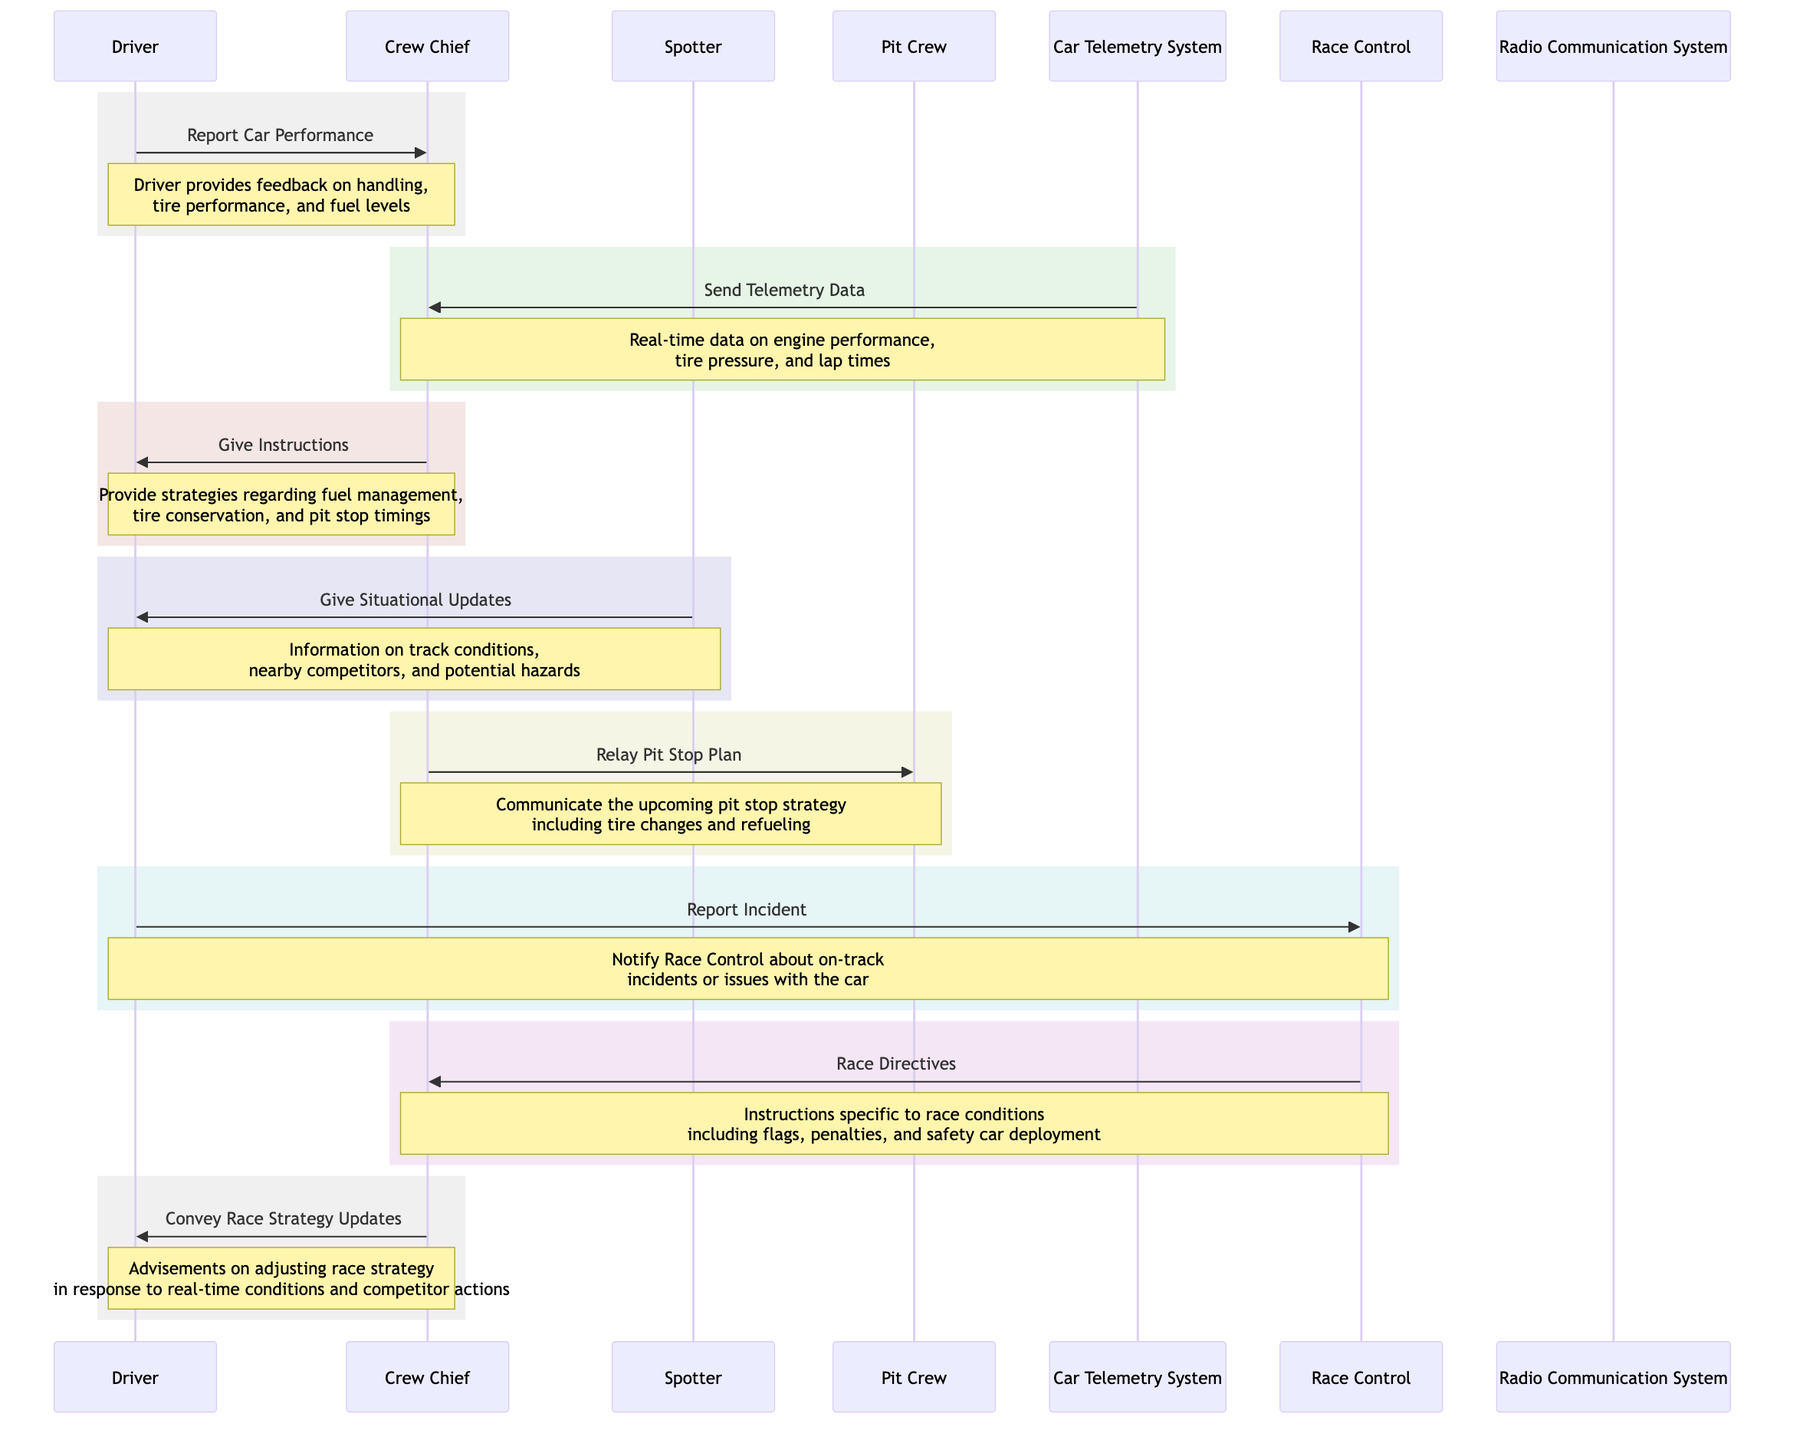What's the first action the Driver takes? The first action is "Report Car Performance," which indicates that the Driver communicates with the Crew Chief to provide feedback on the car's performance. This is the first message shown in the diagram.
Answer: Report Car Performance How many messages does the Crew Chief send? The Crew Chief sends three messages in total: "Give Instructions" to the Driver, "Relay Pit Stop Plan" to the Pit Crew, and "Convey Race Strategy Updates" to the Driver. Counting these gives a total of three messages.
Answer: 3 Who provides situational updates to the Driver? The Spotter is the one who provides situational updates to the Driver, as shown by the message "Give Situational Updates" directed from the Spotter to the Driver in the diagram.
Answer: Spotter What type of data does the Car Telemetry System send? The Car Telemetry System sends "Telemetry Data," which includes real-time data on engine performance, tire pressure, and lap times. This is stated in the corresponding message in the diagram.
Answer: Telemetry Data Which actor is responsible for notifying Race Control about incidents? The Driver is responsible for notifying Race Control about incidents through the message "Report Incident." This is clearly indicated in the sequence when the Driver communicates with Race Control.
Answer: Driver What does Race Control send to the Crew Chief? Race Control sends "Race Directives," which include instructions related to race conditions like flags, penalties, and safety car deployment. This message is sent from Race Control to the Crew Chief as shown in the diagram.
Answer: Race Directives How many actors are involved in this communication sequence? The diagram includes four actors: Driver, Crew Chief, Spotter, and Pit Crew. Counting these actors gives a total of four involved in the communication during the race.
Answer: 4 What is the purpose of the message from the Crew Chief to the Pit Crew? The purpose of the message "Relay Pit Stop Plan" from the Crew Chief to the Pit Crew is to communicate the upcoming pit stop strategy, including tire changes and refueling. This information is explicitly described in the diagram.
Answer: Relay Pit Stop Plan What is communicated after the Driver reports a car incident? After the Driver reports an incident to Race Control, Race Control sends "Race Directives" back to the Crew Chief. This shows a chain of communication following that reported incident.
Answer: Race Directives 